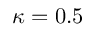Convert formula to latex. <formula><loc_0><loc_0><loc_500><loc_500>\kappa = 0 . 5</formula> 